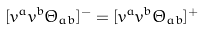<formula> <loc_0><loc_0><loc_500><loc_500>[ v ^ { a } v ^ { b } \Theta _ { a b } ] ^ { - } = [ v ^ { a } v ^ { b } \Theta _ { a b } ] ^ { + }</formula> 